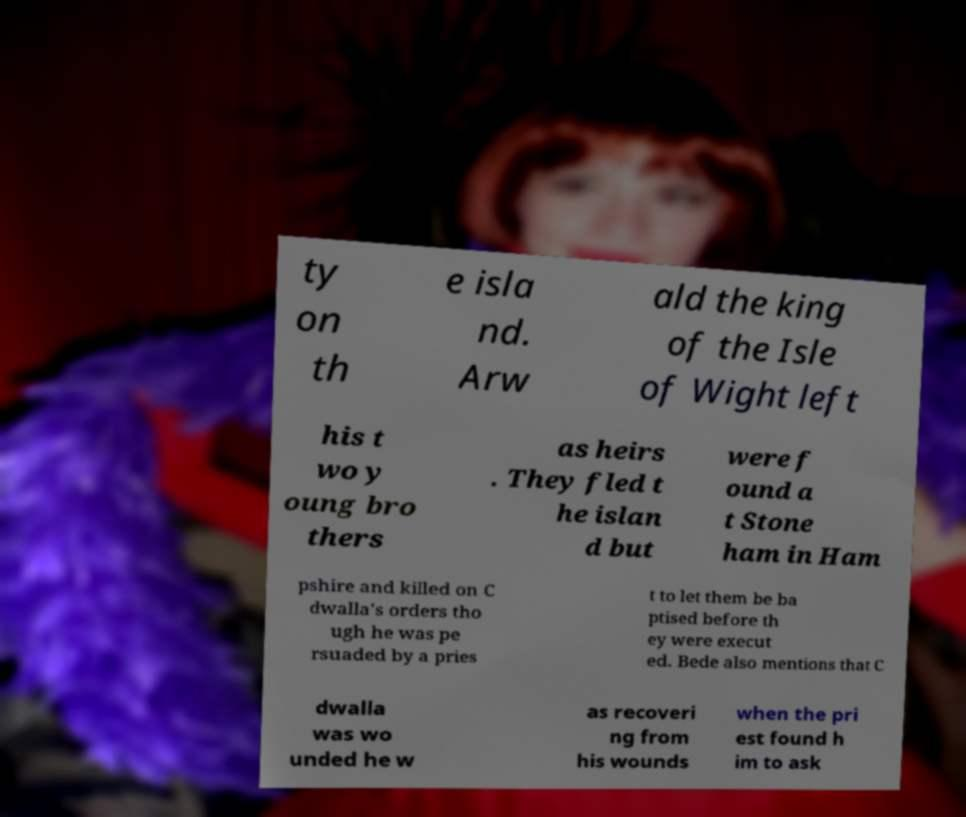Please read and relay the text visible in this image. What does it say? ty on th e isla nd. Arw ald the king of the Isle of Wight left his t wo y oung bro thers as heirs . They fled t he islan d but were f ound a t Stone ham in Ham pshire and killed on C dwalla's orders tho ugh he was pe rsuaded by a pries t to let them be ba ptised before th ey were execut ed. Bede also mentions that C dwalla was wo unded he w as recoveri ng from his wounds when the pri est found h im to ask 